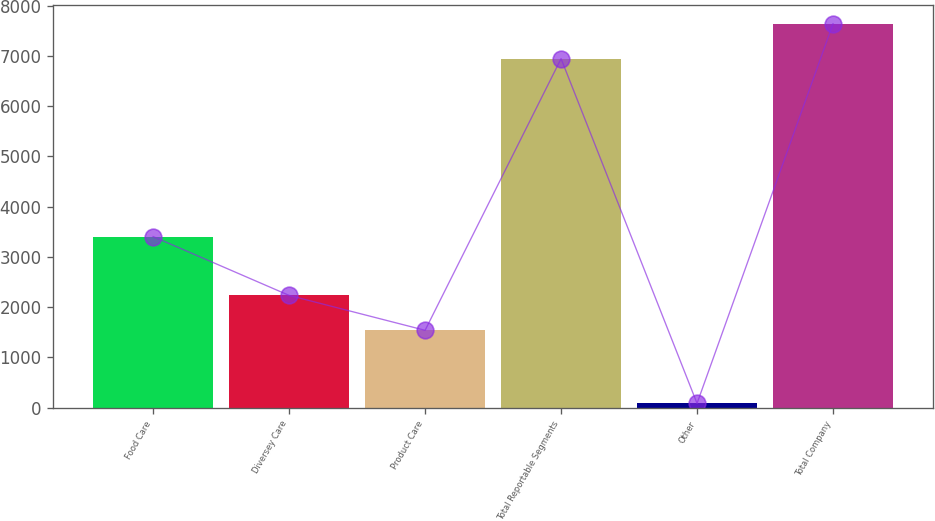Convert chart to OTSL. <chart><loc_0><loc_0><loc_500><loc_500><bar_chart><fcel>Food Care<fcel>Diversey Care<fcel>Product Care<fcel>Total Reportable Segments<fcel>Other<fcel>Total Company<nl><fcel>3405.1<fcel>2234.97<fcel>1540.5<fcel>6944.7<fcel>86.8<fcel>7639.17<nl></chart> 